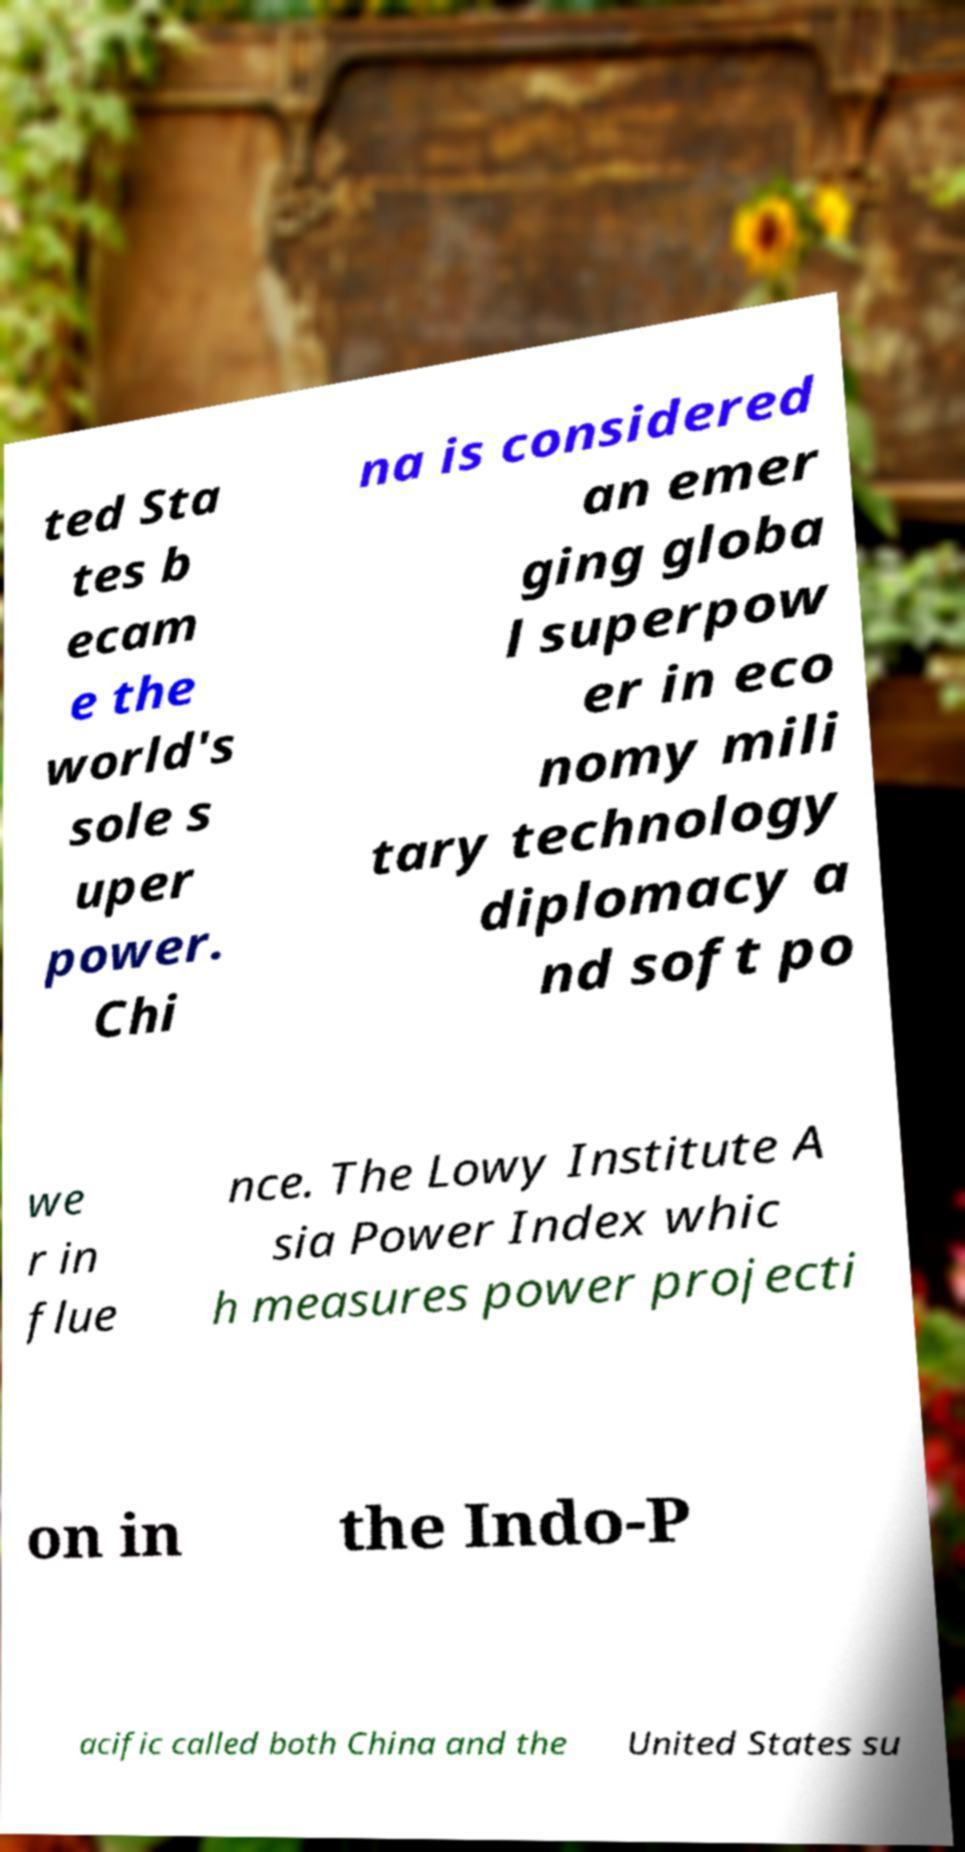For documentation purposes, I need the text within this image transcribed. Could you provide that? ted Sta tes b ecam e the world's sole s uper power. Chi na is considered an emer ging globa l superpow er in eco nomy mili tary technology diplomacy a nd soft po we r in flue nce. The Lowy Institute A sia Power Index whic h measures power projecti on in the Indo-P acific called both China and the United States su 